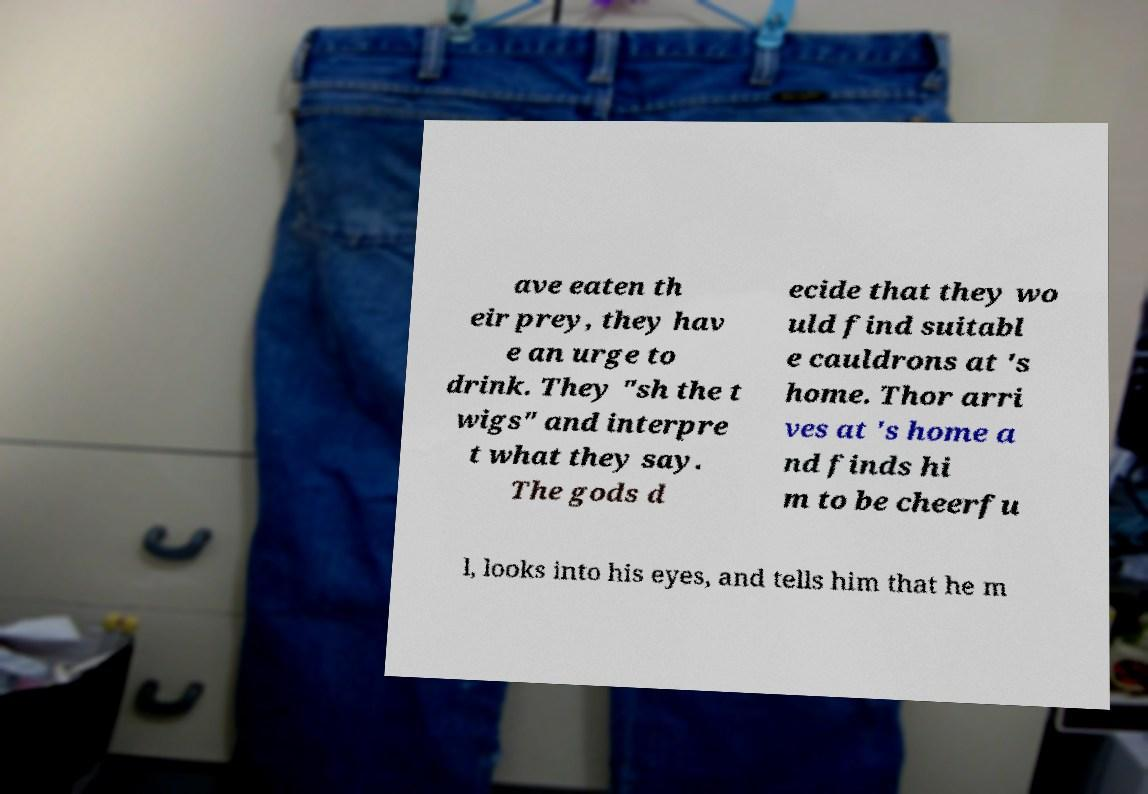Could you assist in decoding the text presented in this image and type it out clearly? ave eaten th eir prey, they hav e an urge to drink. They "sh the t wigs" and interpre t what they say. The gods d ecide that they wo uld find suitabl e cauldrons at 's home. Thor arri ves at 's home a nd finds hi m to be cheerfu l, looks into his eyes, and tells him that he m 